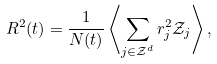<formula> <loc_0><loc_0><loc_500><loc_500>R ^ { 2 } ( t ) = \frac { 1 } { N ( t ) } \left \langle \sum _ { j \in \mathcal { Z } ^ { d } } r _ { j } ^ { 2 } \mathcal { Z } _ { j } \right \rangle ,</formula> 